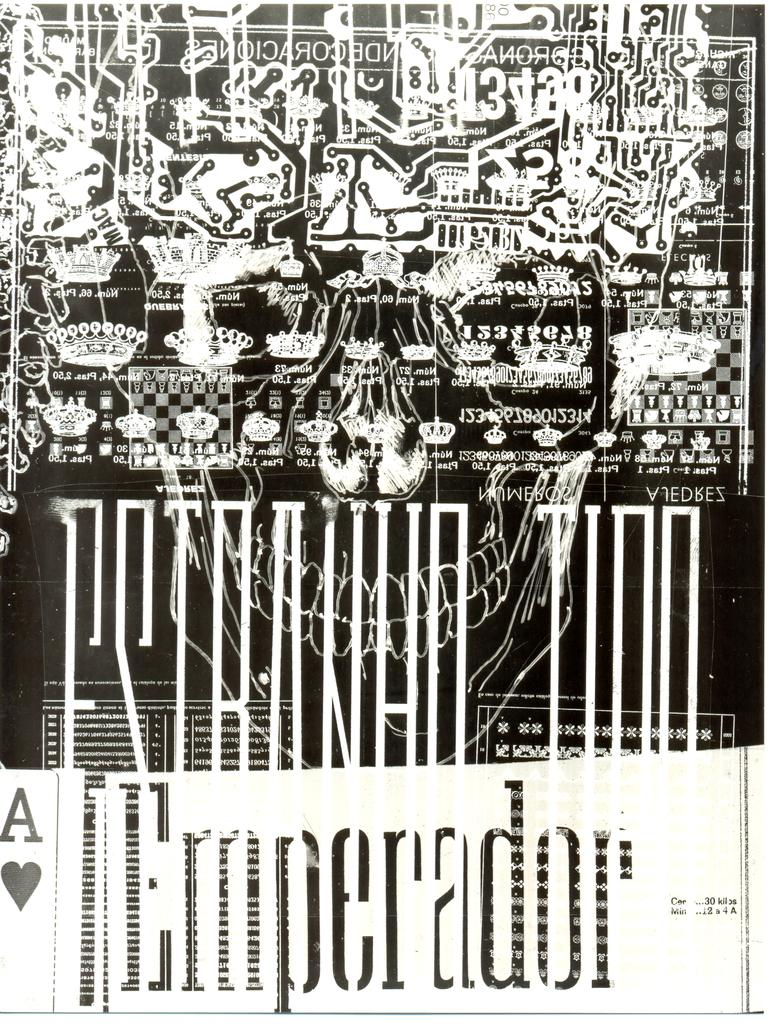<image>
Relay a brief, clear account of the picture shown. A white poster with stylized printing on it and the words "Emperador" displayed below. 